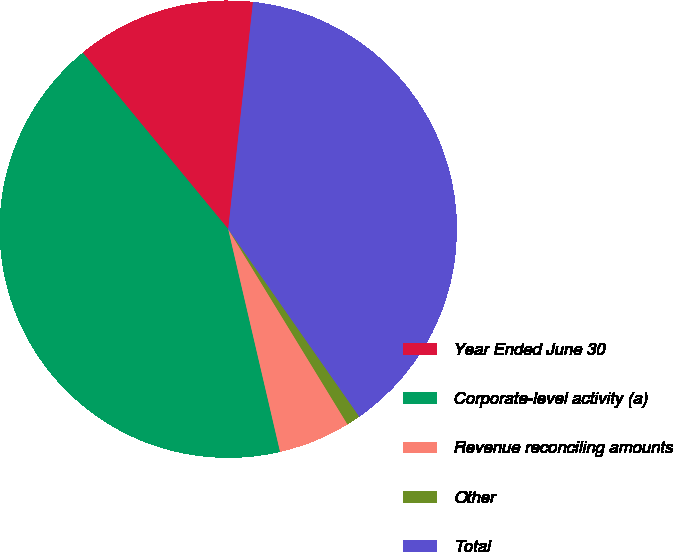<chart> <loc_0><loc_0><loc_500><loc_500><pie_chart><fcel>Year Ended June 30<fcel>Corporate-level activity (a)<fcel>Revenue reconciling amounts<fcel>Other<fcel>Total<nl><fcel>12.7%<fcel>42.67%<fcel>5.09%<fcel>0.98%<fcel>38.56%<nl></chart> 